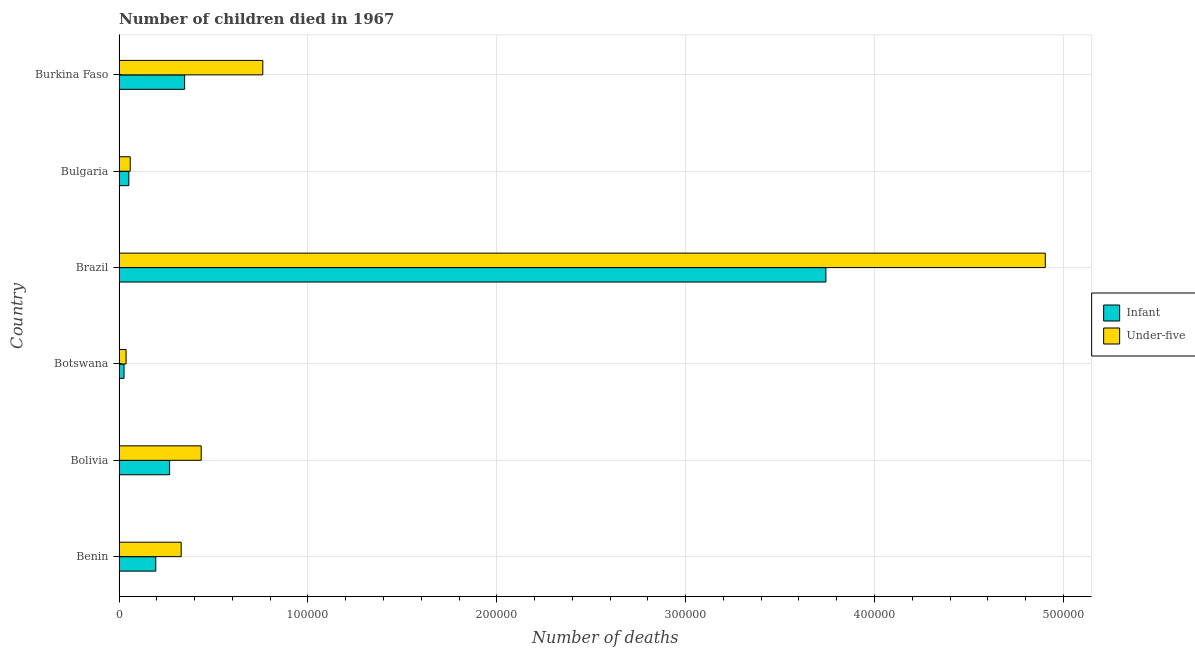How many different coloured bars are there?
Your response must be concise. 2. How many bars are there on the 5th tick from the top?
Provide a short and direct response. 2. How many bars are there on the 6th tick from the bottom?
Your response must be concise. 2. What is the label of the 1st group of bars from the top?
Provide a short and direct response. Burkina Faso. What is the number of under-five deaths in Botswana?
Offer a very short reply. 3716. Across all countries, what is the maximum number of infant deaths?
Provide a short and direct response. 3.74e+05. Across all countries, what is the minimum number of under-five deaths?
Offer a very short reply. 3716. In which country was the number of under-five deaths minimum?
Offer a very short reply. Botswana. What is the total number of infant deaths in the graph?
Offer a terse response. 4.63e+05. What is the difference between the number of infant deaths in Botswana and that in Brazil?
Provide a succinct answer. -3.72e+05. What is the difference between the number of under-five deaths in Bulgaria and the number of infant deaths in Bolivia?
Give a very brief answer. -2.08e+04. What is the average number of under-five deaths per country?
Your response must be concise. 1.09e+05. What is the difference between the number of infant deaths and number of under-five deaths in Brazil?
Give a very brief answer. -1.16e+05. What is the ratio of the number of infant deaths in Botswana to that in Bulgaria?
Your answer should be very brief. 0.51. Is the number of under-five deaths in Botswana less than that in Burkina Faso?
Your answer should be very brief. Yes. Is the difference between the number of under-five deaths in Benin and Bolivia greater than the difference between the number of infant deaths in Benin and Bolivia?
Keep it short and to the point. No. What is the difference between the highest and the second highest number of under-five deaths?
Provide a short and direct response. 4.14e+05. What is the difference between the highest and the lowest number of under-five deaths?
Keep it short and to the point. 4.87e+05. In how many countries, is the number of under-five deaths greater than the average number of under-five deaths taken over all countries?
Your answer should be very brief. 1. Is the sum of the number of infant deaths in Brazil and Bulgaria greater than the maximum number of under-five deaths across all countries?
Keep it short and to the point. No. What does the 1st bar from the top in Burkina Faso represents?
Your response must be concise. Under-five. What does the 1st bar from the bottom in Brazil represents?
Offer a very short reply. Infant. How many countries are there in the graph?
Provide a succinct answer. 6. What is the difference between two consecutive major ticks on the X-axis?
Offer a very short reply. 1.00e+05. Are the values on the major ticks of X-axis written in scientific E-notation?
Give a very brief answer. No. Where does the legend appear in the graph?
Your answer should be compact. Center right. How many legend labels are there?
Your answer should be very brief. 2. What is the title of the graph?
Make the answer very short. Number of children died in 1967. Does "constant 2005 US$" appear as one of the legend labels in the graph?
Your answer should be very brief. No. What is the label or title of the X-axis?
Your response must be concise. Number of deaths. What is the label or title of the Y-axis?
Give a very brief answer. Country. What is the Number of deaths of Infant in Benin?
Your answer should be very brief. 1.95e+04. What is the Number of deaths of Under-five in Benin?
Your response must be concise. 3.29e+04. What is the Number of deaths of Infant in Bolivia?
Offer a very short reply. 2.68e+04. What is the Number of deaths in Under-five in Bolivia?
Your answer should be very brief. 4.35e+04. What is the Number of deaths of Infant in Botswana?
Your answer should be very brief. 2634. What is the Number of deaths of Under-five in Botswana?
Provide a short and direct response. 3716. What is the Number of deaths in Infant in Brazil?
Your response must be concise. 3.74e+05. What is the Number of deaths in Under-five in Brazil?
Your response must be concise. 4.90e+05. What is the Number of deaths of Infant in Bulgaria?
Ensure brevity in your answer.  5188. What is the Number of deaths in Under-five in Bulgaria?
Keep it short and to the point. 5923. What is the Number of deaths in Infant in Burkina Faso?
Offer a terse response. 3.47e+04. What is the Number of deaths of Under-five in Burkina Faso?
Ensure brevity in your answer.  7.61e+04. Across all countries, what is the maximum Number of deaths of Infant?
Your response must be concise. 3.74e+05. Across all countries, what is the maximum Number of deaths in Under-five?
Provide a short and direct response. 4.90e+05. Across all countries, what is the minimum Number of deaths in Infant?
Offer a very short reply. 2634. Across all countries, what is the minimum Number of deaths of Under-five?
Provide a succinct answer. 3716. What is the total Number of deaths in Infant in the graph?
Provide a succinct answer. 4.63e+05. What is the total Number of deaths of Under-five in the graph?
Provide a succinct answer. 6.53e+05. What is the difference between the Number of deaths of Infant in Benin and that in Bolivia?
Ensure brevity in your answer.  -7316. What is the difference between the Number of deaths in Under-five in Benin and that in Bolivia?
Your answer should be very brief. -1.06e+04. What is the difference between the Number of deaths of Infant in Benin and that in Botswana?
Your answer should be very brief. 1.68e+04. What is the difference between the Number of deaths of Under-five in Benin and that in Botswana?
Ensure brevity in your answer.  2.92e+04. What is the difference between the Number of deaths in Infant in Benin and that in Brazil?
Make the answer very short. -3.55e+05. What is the difference between the Number of deaths in Under-five in Benin and that in Brazil?
Keep it short and to the point. -4.58e+05. What is the difference between the Number of deaths in Infant in Benin and that in Bulgaria?
Your answer should be very brief. 1.43e+04. What is the difference between the Number of deaths of Under-five in Benin and that in Bulgaria?
Your answer should be very brief. 2.70e+04. What is the difference between the Number of deaths of Infant in Benin and that in Burkina Faso?
Provide a short and direct response. -1.53e+04. What is the difference between the Number of deaths in Under-five in Benin and that in Burkina Faso?
Your response must be concise. -4.32e+04. What is the difference between the Number of deaths of Infant in Bolivia and that in Botswana?
Your response must be concise. 2.41e+04. What is the difference between the Number of deaths of Under-five in Bolivia and that in Botswana?
Make the answer very short. 3.98e+04. What is the difference between the Number of deaths in Infant in Bolivia and that in Brazil?
Offer a terse response. -3.48e+05. What is the difference between the Number of deaths of Under-five in Bolivia and that in Brazil?
Make the answer very short. -4.47e+05. What is the difference between the Number of deaths in Infant in Bolivia and that in Bulgaria?
Ensure brevity in your answer.  2.16e+04. What is the difference between the Number of deaths in Under-five in Bolivia and that in Bulgaria?
Your answer should be very brief. 3.76e+04. What is the difference between the Number of deaths in Infant in Bolivia and that in Burkina Faso?
Keep it short and to the point. -7951. What is the difference between the Number of deaths in Under-five in Bolivia and that in Burkina Faso?
Provide a succinct answer. -3.26e+04. What is the difference between the Number of deaths of Infant in Botswana and that in Brazil?
Offer a terse response. -3.72e+05. What is the difference between the Number of deaths in Under-five in Botswana and that in Brazil?
Your response must be concise. -4.87e+05. What is the difference between the Number of deaths of Infant in Botswana and that in Bulgaria?
Give a very brief answer. -2554. What is the difference between the Number of deaths of Under-five in Botswana and that in Bulgaria?
Give a very brief answer. -2207. What is the difference between the Number of deaths in Infant in Botswana and that in Burkina Faso?
Your answer should be compact. -3.21e+04. What is the difference between the Number of deaths of Under-five in Botswana and that in Burkina Faso?
Provide a short and direct response. -7.24e+04. What is the difference between the Number of deaths of Infant in Brazil and that in Bulgaria?
Give a very brief answer. 3.69e+05. What is the difference between the Number of deaths in Under-five in Brazil and that in Bulgaria?
Your answer should be very brief. 4.85e+05. What is the difference between the Number of deaths in Infant in Brazil and that in Burkina Faso?
Make the answer very short. 3.40e+05. What is the difference between the Number of deaths in Under-five in Brazil and that in Burkina Faso?
Make the answer very short. 4.14e+05. What is the difference between the Number of deaths in Infant in Bulgaria and that in Burkina Faso?
Ensure brevity in your answer.  -2.95e+04. What is the difference between the Number of deaths of Under-five in Bulgaria and that in Burkina Faso?
Ensure brevity in your answer.  -7.02e+04. What is the difference between the Number of deaths of Infant in Benin and the Number of deaths of Under-five in Bolivia?
Offer a very short reply. -2.40e+04. What is the difference between the Number of deaths of Infant in Benin and the Number of deaths of Under-five in Botswana?
Your answer should be very brief. 1.57e+04. What is the difference between the Number of deaths of Infant in Benin and the Number of deaths of Under-five in Brazil?
Make the answer very short. -4.71e+05. What is the difference between the Number of deaths in Infant in Benin and the Number of deaths in Under-five in Bulgaria?
Provide a succinct answer. 1.35e+04. What is the difference between the Number of deaths of Infant in Benin and the Number of deaths of Under-five in Burkina Faso?
Give a very brief answer. -5.67e+04. What is the difference between the Number of deaths in Infant in Bolivia and the Number of deaths in Under-five in Botswana?
Make the answer very short. 2.31e+04. What is the difference between the Number of deaths in Infant in Bolivia and the Number of deaths in Under-five in Brazil?
Keep it short and to the point. -4.64e+05. What is the difference between the Number of deaths of Infant in Bolivia and the Number of deaths of Under-five in Bulgaria?
Provide a succinct answer. 2.08e+04. What is the difference between the Number of deaths in Infant in Bolivia and the Number of deaths in Under-five in Burkina Faso?
Offer a terse response. -4.93e+04. What is the difference between the Number of deaths of Infant in Botswana and the Number of deaths of Under-five in Brazil?
Offer a very short reply. -4.88e+05. What is the difference between the Number of deaths of Infant in Botswana and the Number of deaths of Under-five in Bulgaria?
Your answer should be compact. -3289. What is the difference between the Number of deaths in Infant in Botswana and the Number of deaths in Under-five in Burkina Faso?
Your answer should be very brief. -7.35e+04. What is the difference between the Number of deaths of Infant in Brazil and the Number of deaths of Under-five in Bulgaria?
Keep it short and to the point. 3.68e+05. What is the difference between the Number of deaths in Infant in Brazil and the Number of deaths in Under-five in Burkina Faso?
Ensure brevity in your answer.  2.98e+05. What is the difference between the Number of deaths of Infant in Bulgaria and the Number of deaths of Under-five in Burkina Faso?
Offer a very short reply. -7.09e+04. What is the average Number of deaths of Infant per country?
Keep it short and to the point. 7.72e+04. What is the average Number of deaths in Under-five per country?
Provide a succinct answer. 1.09e+05. What is the difference between the Number of deaths of Infant and Number of deaths of Under-five in Benin?
Provide a succinct answer. -1.34e+04. What is the difference between the Number of deaths of Infant and Number of deaths of Under-five in Bolivia?
Keep it short and to the point. -1.67e+04. What is the difference between the Number of deaths of Infant and Number of deaths of Under-five in Botswana?
Offer a terse response. -1082. What is the difference between the Number of deaths in Infant and Number of deaths in Under-five in Brazil?
Ensure brevity in your answer.  -1.16e+05. What is the difference between the Number of deaths of Infant and Number of deaths of Under-five in Bulgaria?
Make the answer very short. -735. What is the difference between the Number of deaths in Infant and Number of deaths in Under-five in Burkina Faso?
Keep it short and to the point. -4.14e+04. What is the ratio of the Number of deaths in Infant in Benin to that in Bolivia?
Your response must be concise. 0.73. What is the ratio of the Number of deaths in Under-five in Benin to that in Bolivia?
Offer a very short reply. 0.76. What is the ratio of the Number of deaths of Infant in Benin to that in Botswana?
Ensure brevity in your answer.  7.38. What is the ratio of the Number of deaths in Under-five in Benin to that in Botswana?
Provide a short and direct response. 8.85. What is the ratio of the Number of deaths of Infant in Benin to that in Brazil?
Give a very brief answer. 0.05. What is the ratio of the Number of deaths in Under-five in Benin to that in Brazil?
Provide a short and direct response. 0.07. What is the ratio of the Number of deaths in Infant in Benin to that in Bulgaria?
Keep it short and to the point. 3.75. What is the ratio of the Number of deaths in Under-five in Benin to that in Bulgaria?
Offer a very short reply. 5.55. What is the ratio of the Number of deaths of Infant in Benin to that in Burkina Faso?
Provide a short and direct response. 0.56. What is the ratio of the Number of deaths in Under-five in Benin to that in Burkina Faso?
Ensure brevity in your answer.  0.43. What is the ratio of the Number of deaths of Infant in Bolivia to that in Botswana?
Give a very brief answer. 10.16. What is the ratio of the Number of deaths in Under-five in Bolivia to that in Botswana?
Offer a very short reply. 11.71. What is the ratio of the Number of deaths in Infant in Bolivia to that in Brazil?
Offer a terse response. 0.07. What is the ratio of the Number of deaths in Under-five in Bolivia to that in Brazil?
Give a very brief answer. 0.09. What is the ratio of the Number of deaths of Infant in Bolivia to that in Bulgaria?
Offer a very short reply. 5.16. What is the ratio of the Number of deaths of Under-five in Bolivia to that in Bulgaria?
Ensure brevity in your answer.  7.34. What is the ratio of the Number of deaths of Infant in Bolivia to that in Burkina Faso?
Keep it short and to the point. 0.77. What is the ratio of the Number of deaths of Under-five in Bolivia to that in Burkina Faso?
Provide a short and direct response. 0.57. What is the ratio of the Number of deaths in Infant in Botswana to that in Brazil?
Your answer should be very brief. 0.01. What is the ratio of the Number of deaths in Under-five in Botswana to that in Brazil?
Keep it short and to the point. 0.01. What is the ratio of the Number of deaths in Infant in Botswana to that in Bulgaria?
Provide a succinct answer. 0.51. What is the ratio of the Number of deaths in Under-five in Botswana to that in Bulgaria?
Provide a short and direct response. 0.63. What is the ratio of the Number of deaths in Infant in Botswana to that in Burkina Faso?
Your answer should be very brief. 0.08. What is the ratio of the Number of deaths of Under-five in Botswana to that in Burkina Faso?
Your answer should be compact. 0.05. What is the ratio of the Number of deaths in Infant in Brazil to that in Bulgaria?
Keep it short and to the point. 72.14. What is the ratio of the Number of deaths of Under-five in Brazil to that in Bulgaria?
Your answer should be very brief. 82.8. What is the ratio of the Number of deaths of Infant in Brazil to that in Burkina Faso?
Your answer should be very brief. 10.78. What is the ratio of the Number of deaths in Under-five in Brazil to that in Burkina Faso?
Offer a very short reply. 6.44. What is the ratio of the Number of deaths in Infant in Bulgaria to that in Burkina Faso?
Give a very brief answer. 0.15. What is the ratio of the Number of deaths in Under-five in Bulgaria to that in Burkina Faso?
Make the answer very short. 0.08. What is the difference between the highest and the second highest Number of deaths in Infant?
Your answer should be very brief. 3.40e+05. What is the difference between the highest and the second highest Number of deaths of Under-five?
Offer a terse response. 4.14e+05. What is the difference between the highest and the lowest Number of deaths of Infant?
Offer a very short reply. 3.72e+05. What is the difference between the highest and the lowest Number of deaths of Under-five?
Your answer should be compact. 4.87e+05. 